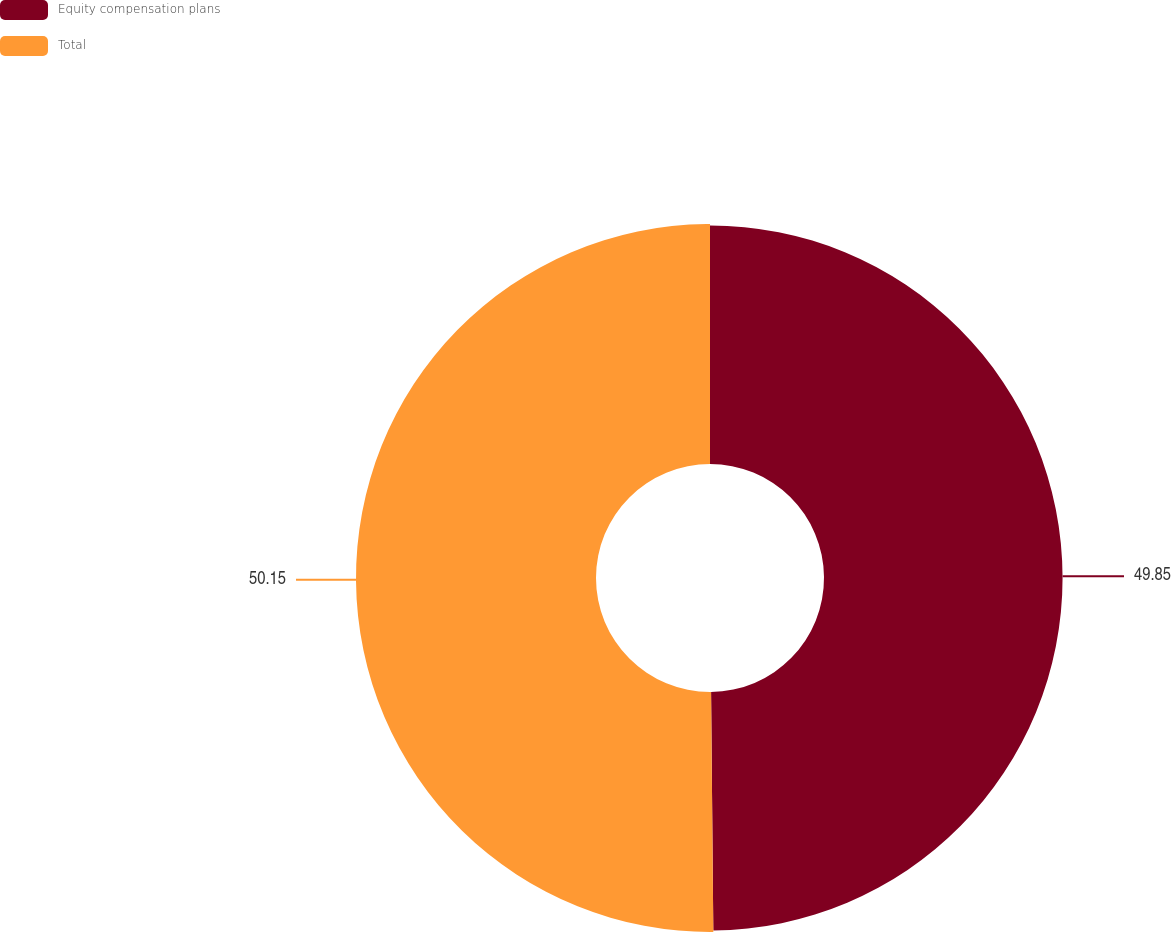Convert chart. <chart><loc_0><loc_0><loc_500><loc_500><pie_chart><fcel>Equity compensation plans<fcel>Total<nl><fcel>49.85%<fcel>50.15%<nl></chart> 